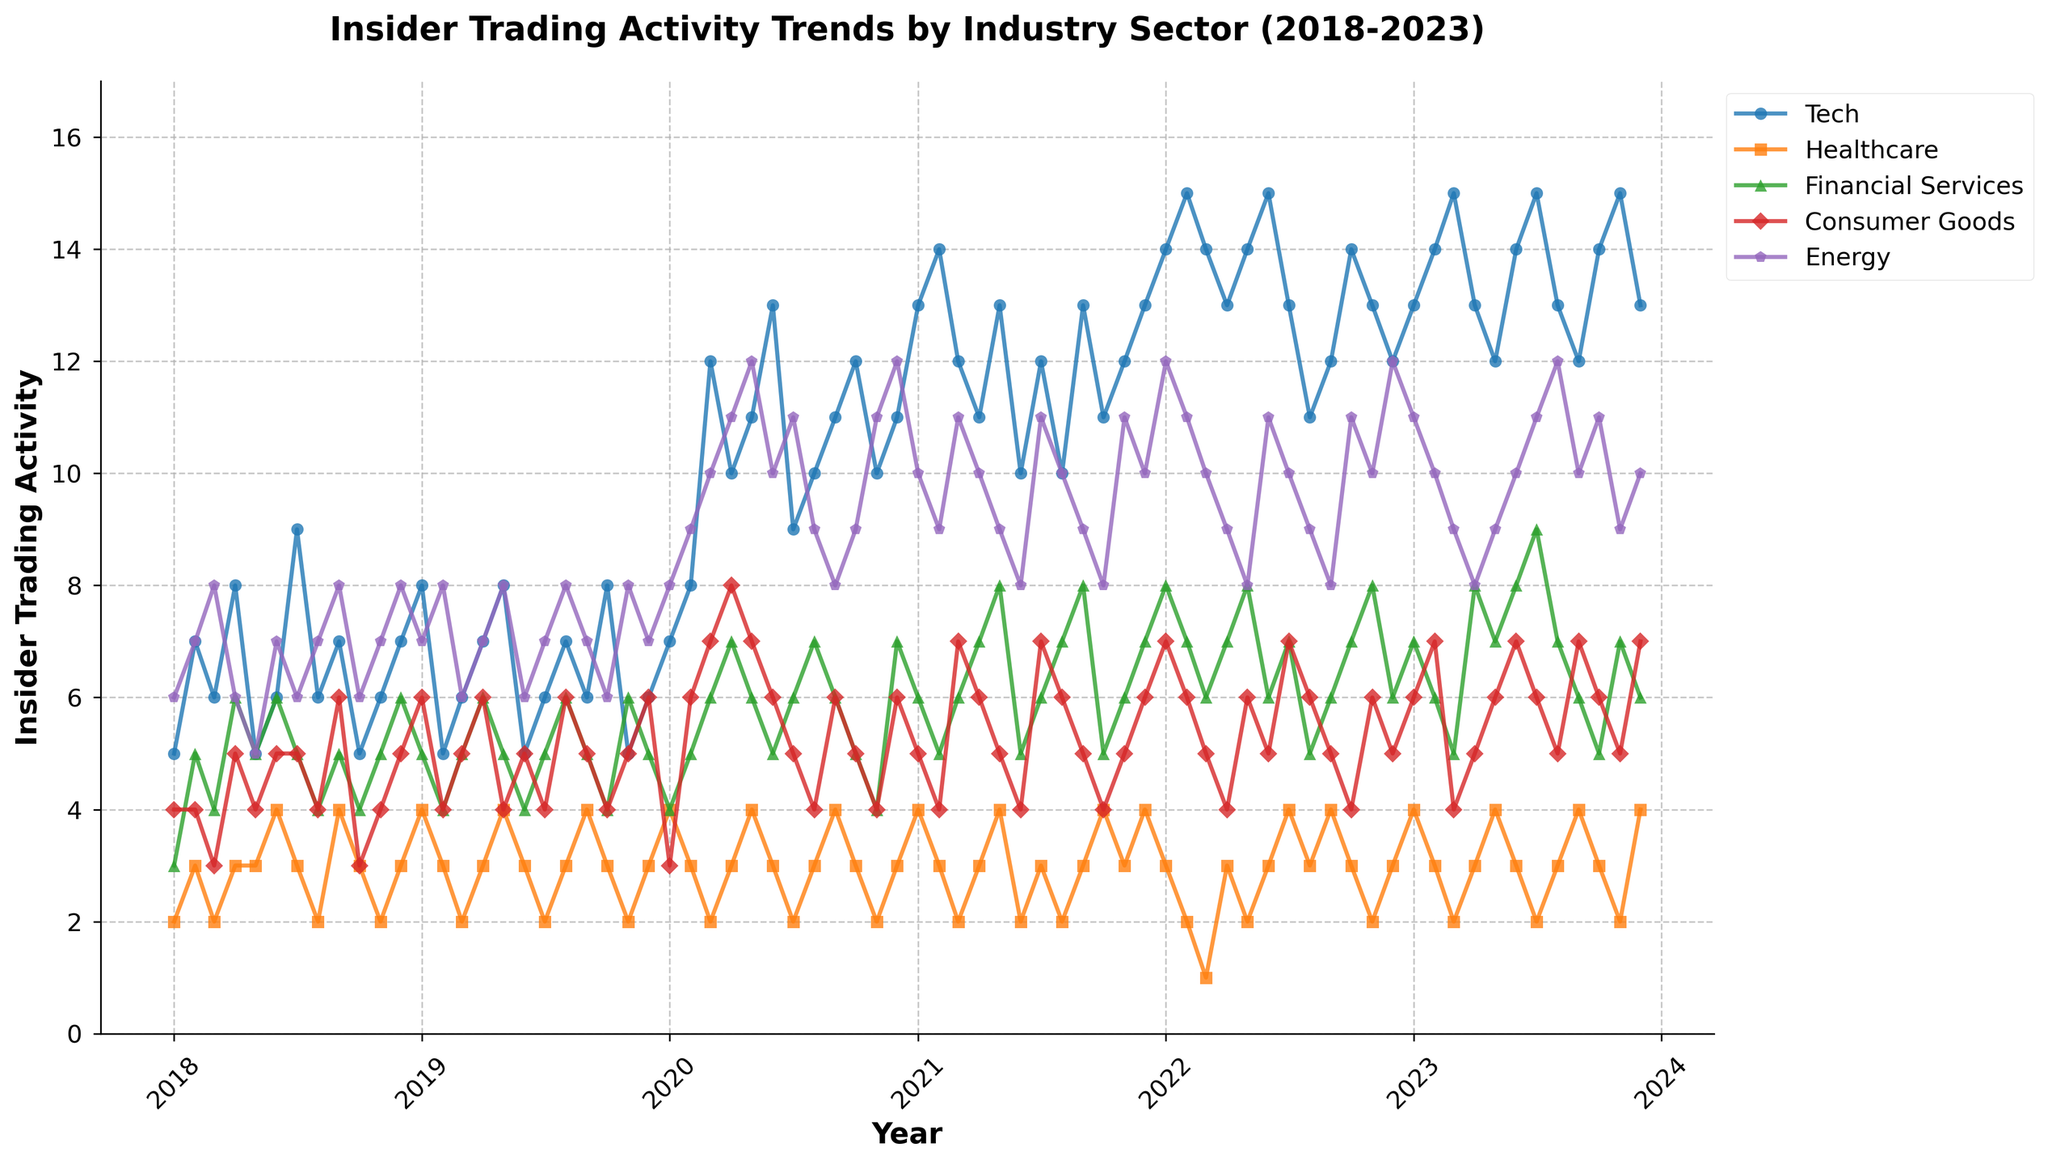What is the overall trend in insider trading activity in the Tech sector from 2018 to 2023? Looking at the plot line and the points for the Tech sector, there is a noticeable upward trend in insider trading activity over the years. It starts relatively lower in 2018 and generally increases, peaking several times, especially around 2021 and 2022.
Answer: Upward trend In which month and year did the Energy sector have its highest insider trading activity? By locating the highest point on the Energy sector's plot line, the peak insider trading activity occurs in May 2020.
Answer: May 2020 Which sector shows the most consistent pattern in its insider trading activity over the five-year period? The Financial Services sector demonstrates the most consistent pattern with relatively stable fluctuations and no drastic changes over the years, as reflected in a generally steady line without sharp peaks or drops.
Answer: Financial Services How does the Consumer Goods sector's insider trading activity in the 2020-2021 period compare to other sectors during the same period? For most of 2020 and 2021, the Consumer Goods sector exhibits higher levels of insider trading activity than the Healthcare and Financial Services sectors. However, it tends to be lower or similar compared to Tech and Energy sectors which have more pronounced increases during the same period.
Answer: Higher than Healthcare and Financial Services, lower than Tech and Energy What's the difference between the peak insider trading activities for the Tech and Healthcare sectors? The peak insider trading activity for the Tech sector is 15 in March 2023, while for the Healthcare sector, it is 4 in several months including September 2020 and November 2023. The difference between these peaks is 15 - 4 = 11.
Answer: 11 Which sector had the highest variation in insider trading activities over the entire period? By observing the rise and fall patterns in the plot lines, the Tech sector demonstrates the highest variation with significant peaks and troughs, while other sectors have more moderate changes.
Answer: Tech During which year did the Financial Services sector experience the most spikes in insider trading activities? Examining the data points for the Financial Services sector, there are noticeable spikes in the year 2021, with peaks occurring in May, August, and September.
Answer: 2021 What is the average insider trading activity in the Energy sector across the five years? Sum the values for the Energy sector over the five years and divide by the number of data points (72 data points corresponding to 72 months):
(6+7+8+6+5+7+6+7+8+6+7+8+7+8+6+7+8+6+7+8+7+8+6+7+8+7+8+10+11+12+10+9+8+9+11+12+10+9+11+9+8+11+10+11+12+11+12+12+10+9+8+11+12+11+10+9+11+10+11+9+10) / 72 ≈ 8.39
Answer: 8.39 How does the trend in insider trading activity for Tech compare to Energy in the year 2020? The trend for Tech in 2020 shows a significant increase, especially starting from March onward, with several high peaks. The Energy sector also shows an increasing trend in the same period, peaking around May and June. Both sectors have increasing trends, but the Tech sector shows more significant spikes.
Answer: Both increasing, Tech has higher spikes What is the relative position of the Healthcare sector's insider trading activity compared to the other sectors over the five-year period? The Healthcare sector's insider trading activity is consistently on the lower end compared to other sectors. It mostly stays near the bottom of the plot, with fewer and less pronounced peaks.
Answer: Lower end 